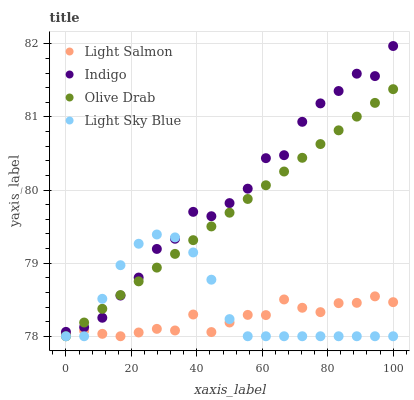Does Light Salmon have the minimum area under the curve?
Answer yes or no. Yes. Does Indigo have the maximum area under the curve?
Answer yes or no. Yes. Does Light Sky Blue have the minimum area under the curve?
Answer yes or no. No. Does Light Sky Blue have the maximum area under the curve?
Answer yes or no. No. Is Olive Drab the smoothest?
Answer yes or no. Yes. Is Indigo the roughest?
Answer yes or no. Yes. Is Light Sky Blue the smoothest?
Answer yes or no. No. Is Light Sky Blue the roughest?
Answer yes or no. No. Does Light Salmon have the lowest value?
Answer yes or no. Yes. Does Indigo have the lowest value?
Answer yes or no. No. Does Indigo have the highest value?
Answer yes or no. Yes. Does Light Sky Blue have the highest value?
Answer yes or no. No. Is Light Salmon less than Indigo?
Answer yes or no. Yes. Is Indigo greater than Light Salmon?
Answer yes or no. Yes. Does Olive Drab intersect Light Sky Blue?
Answer yes or no. Yes. Is Olive Drab less than Light Sky Blue?
Answer yes or no. No. Is Olive Drab greater than Light Sky Blue?
Answer yes or no. No. Does Light Salmon intersect Indigo?
Answer yes or no. No. 